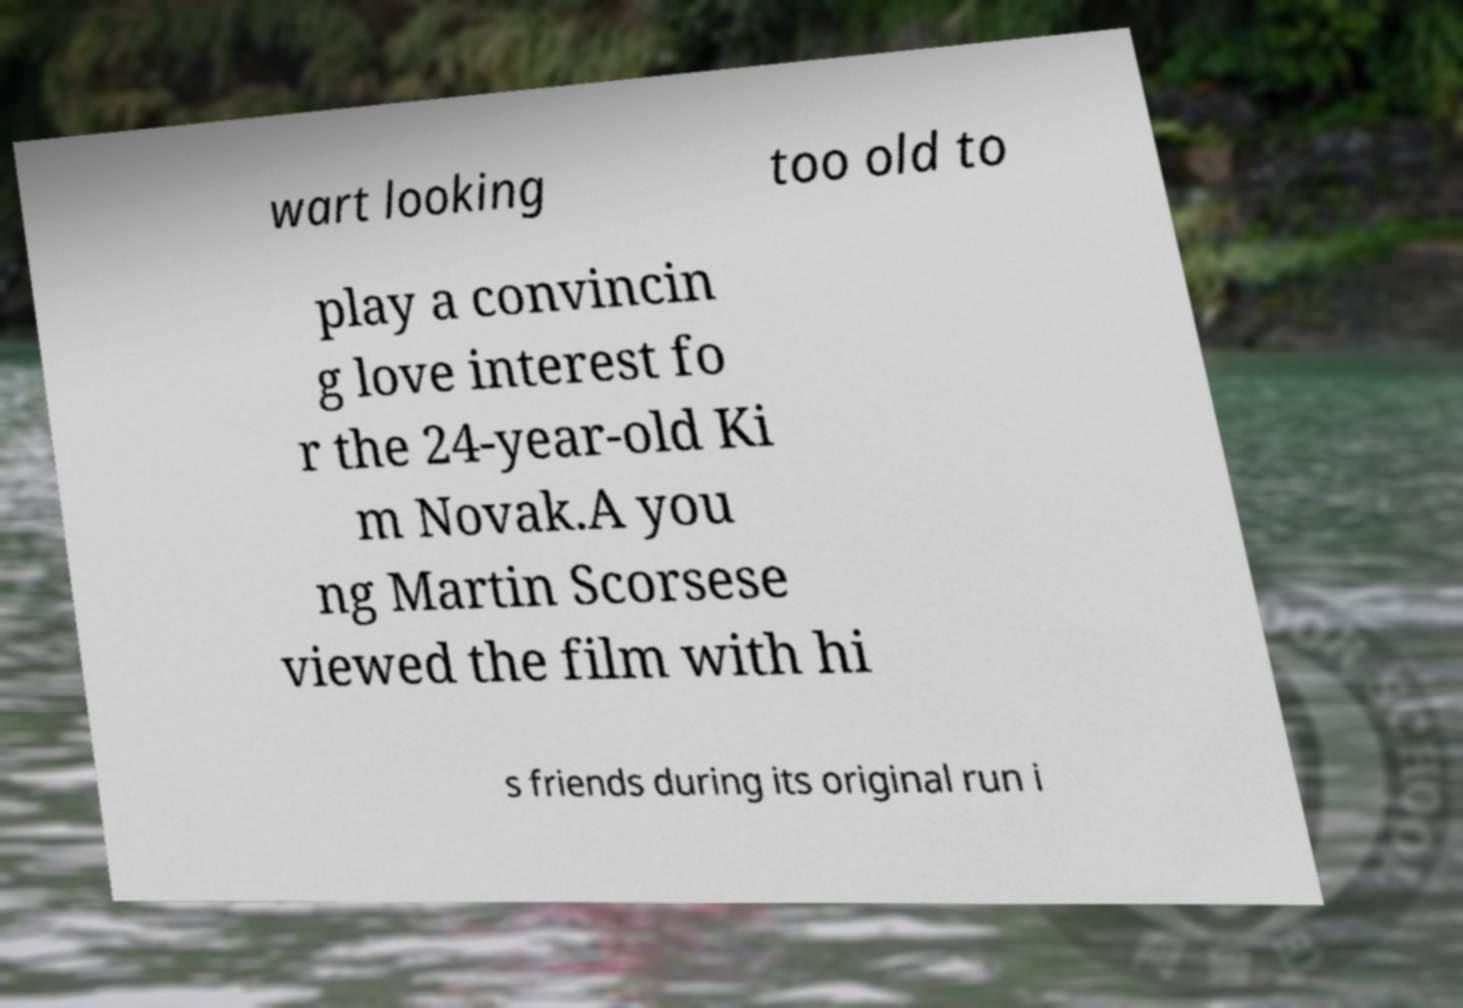Could you extract and type out the text from this image? wart looking too old to play a convincin g love interest fo r the 24-year-old Ki m Novak.A you ng Martin Scorsese viewed the film with hi s friends during its original run i 